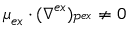Convert formula to latex. <formula><loc_0><loc_0><loc_500><loc_500>\mu _ { e x } \cdot ( \nabla ^ { e x } ) _ { \mathcal { P } ^ { e x } } \neq 0</formula> 